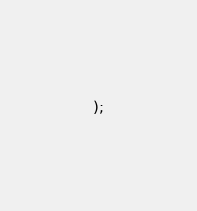Convert code to text. <code><loc_0><loc_0><loc_500><loc_500><_SQL_>);
</code> 